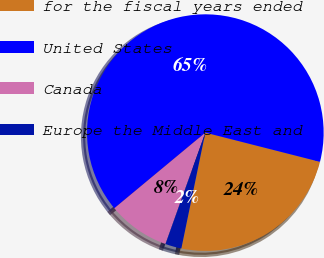<chart> <loc_0><loc_0><loc_500><loc_500><pie_chart><fcel>for the fiscal years ended<fcel>United States<fcel>Canada<fcel>Europe the Middle East and<nl><fcel>24.28%<fcel>65.0%<fcel>8.5%<fcel>2.22%<nl></chart> 